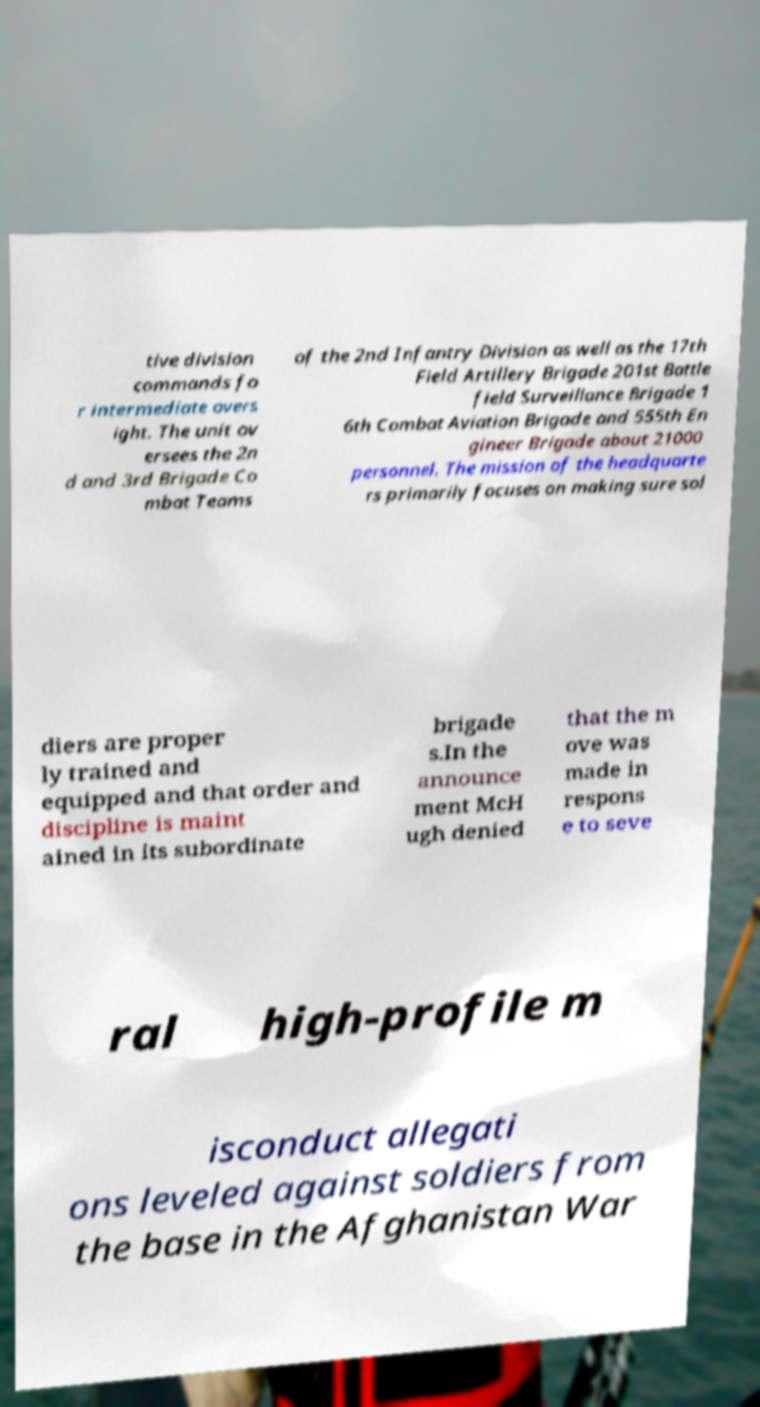What messages or text are displayed in this image? I need them in a readable, typed format. tive division commands fo r intermediate overs ight. The unit ov ersees the 2n d and 3rd Brigade Co mbat Teams of the 2nd Infantry Division as well as the 17th Field Artillery Brigade 201st Battle field Surveillance Brigade 1 6th Combat Aviation Brigade and 555th En gineer Brigade about 21000 personnel. The mission of the headquarte rs primarily focuses on making sure sol diers are proper ly trained and equipped and that order and discipline is maint ained in its subordinate brigade s.In the announce ment McH ugh denied that the m ove was made in respons e to seve ral high-profile m isconduct allegati ons leveled against soldiers from the base in the Afghanistan War 